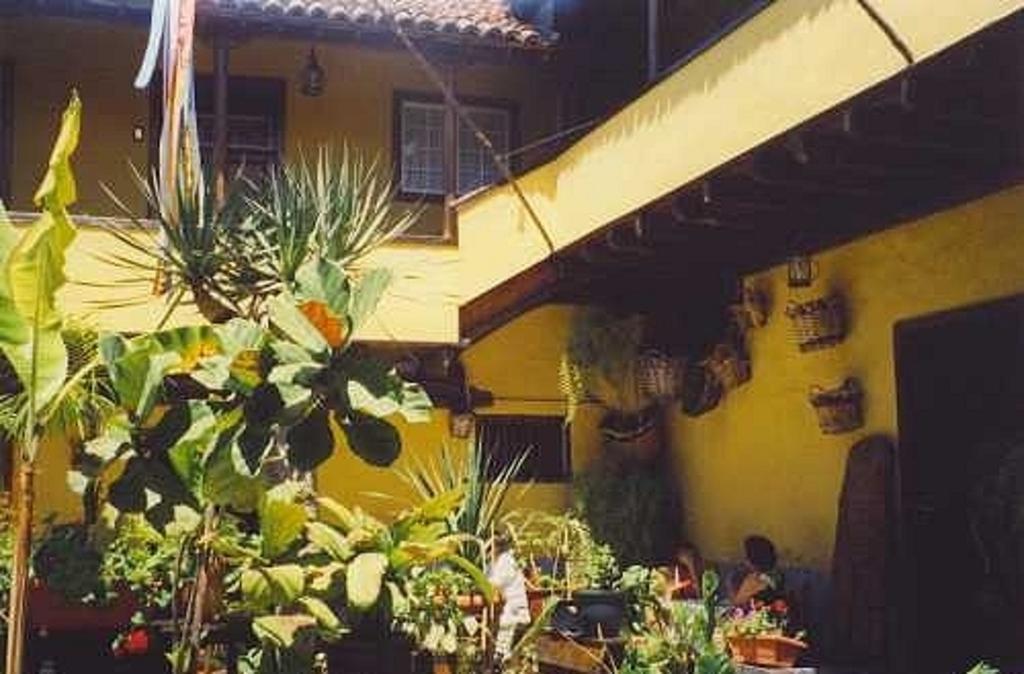In one or two sentences, can you explain what this image depicts? In this image there is a building and we can see plants. There are trees. We can see baskets and there are windows. 